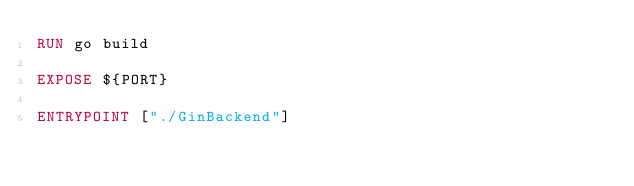Convert code to text. <code><loc_0><loc_0><loc_500><loc_500><_Dockerfile_>RUN go build

EXPOSE ${PORT}

ENTRYPOINT ["./GinBackend"]</code> 